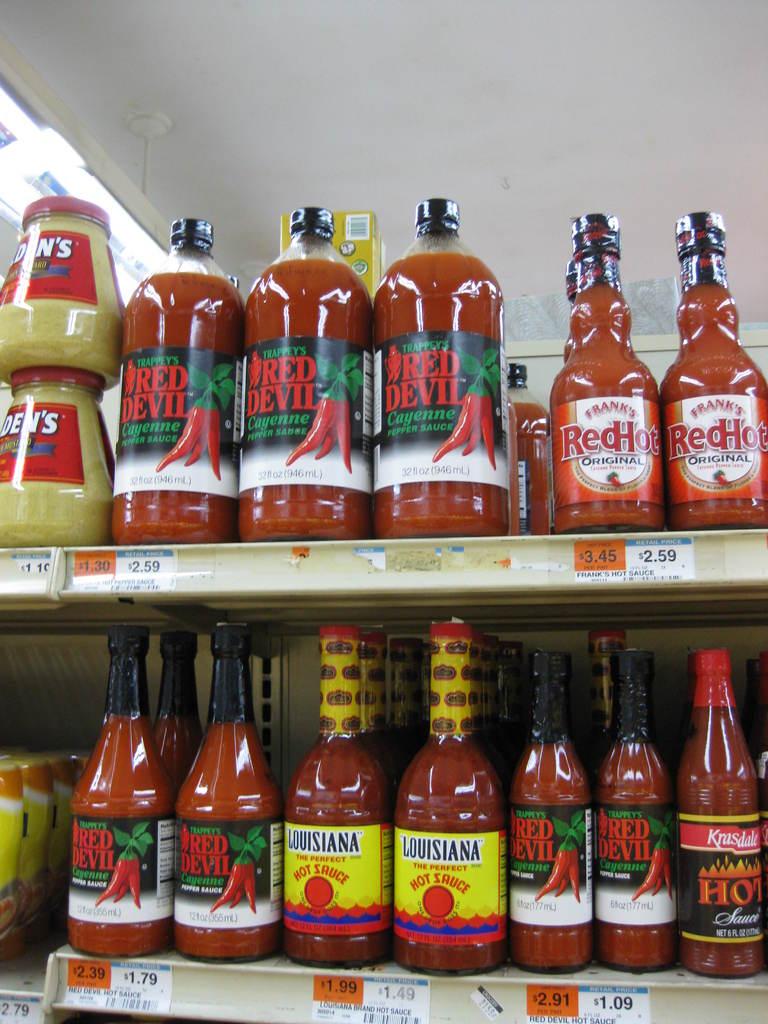What kind of sauce is on the top right?
Your response must be concise. Red hot. What state is the hot sauce with the yellow label from?
Make the answer very short. Louisiana. 